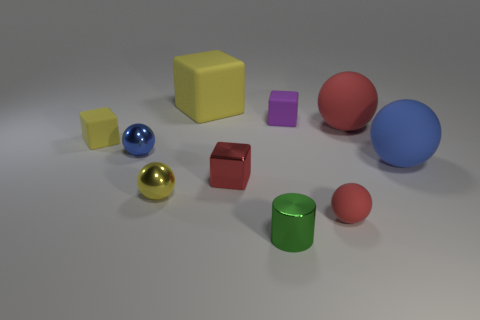What is the shape of the green thing that is the same size as the red shiny object?
Offer a terse response. Cylinder. The green object is what shape?
Give a very brief answer. Cylinder. Do the large yellow thing right of the tiny blue sphere and the green cylinder have the same material?
Give a very brief answer. No. What size is the yellow block in front of the small rubber cube that is on the right side of the small green metal thing?
Ensure brevity in your answer.  Small. There is a sphere that is both behind the blue rubber thing and right of the small rubber sphere; what color is it?
Your response must be concise. Red. What material is the blue object that is the same size as the green thing?
Offer a terse response. Metal. How many other things are there of the same material as the big yellow block?
Provide a succinct answer. 5. Do the rubber block that is in front of the big red ball and the big thing that is on the left side of the purple rubber thing have the same color?
Provide a short and direct response. Yes. What is the shape of the blue thing on the left side of the matte block right of the tiny green metallic cylinder?
Offer a very short reply. Sphere. What number of other things are the same color as the small rubber sphere?
Offer a terse response. 2. 